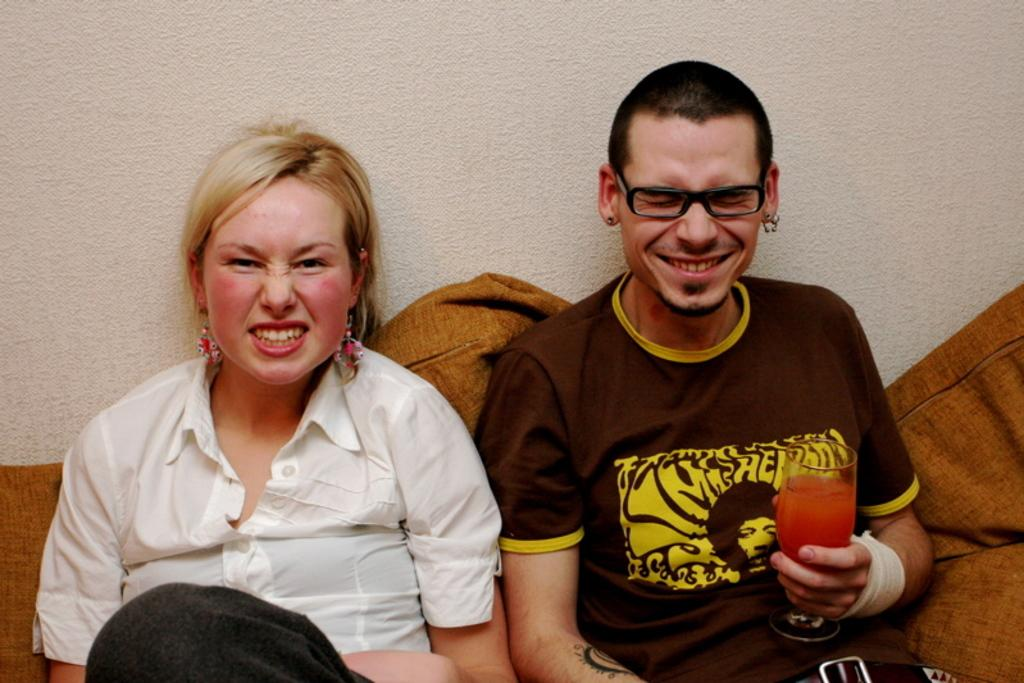How many people are sitting on the sofa in the image? There are two persons sitting on a sofa in the image. What is one person holding in their hand? One person is holding a glass in their hand. What can be seen in the background of the image? There is a wall in the background. What type of room might the image be taken in? The image is likely taken in a hall. What type of rod can be seen hanging from the ceiling in the image? There is no rod hanging from the ceiling in the image. How many squares are visible on the wall in the image? There is no mention of squares on the wall in the image. Is there a spy observing the two persons sitting on the sofa in the image? There is no indication of a spy or any other person observing the two persons in the image. 